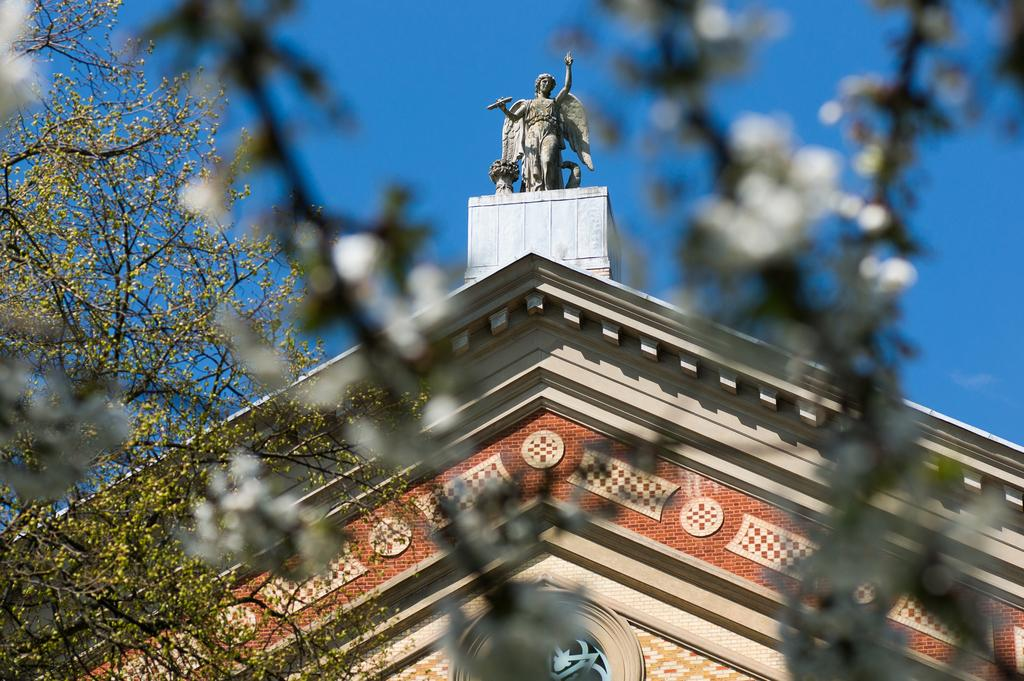What type of structure is present in the image? There is a building in the image. What is located on the building? There is a statue on the building. What can be seen on the left side of the image? A plant is visible on the left side of the image. What is the color of the sky in the image? The sky is blue in color. Can you tell me how many firemen are visible in the image? There are no firemen present in the image. What part of the plant is breathing in the image? Plants do not breathe in the same way as animals, and there is no indication of a specific part of the plant breathing in the image. 